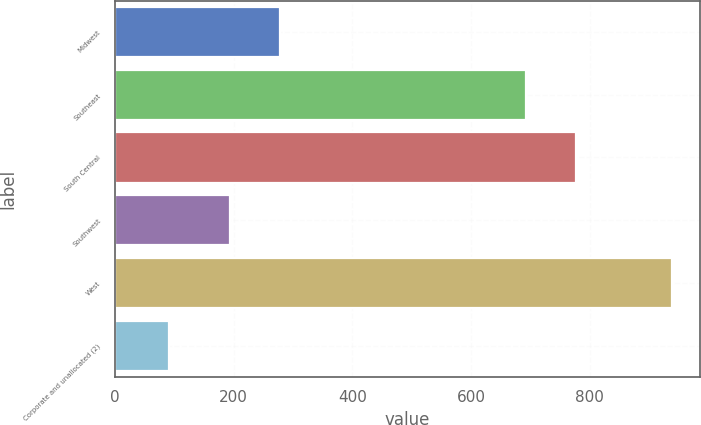Convert chart to OTSL. <chart><loc_0><loc_0><loc_500><loc_500><bar_chart><fcel>Midwest<fcel>Southeast<fcel>South Central<fcel>Southwest<fcel>West<fcel>Corporate and unallocated (2)<nl><fcel>278.39<fcel>692.9<fcel>777.69<fcel>193.6<fcel>938.4<fcel>90.5<nl></chart> 